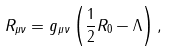<formula> <loc_0><loc_0><loc_500><loc_500>R _ { \mu \nu } = g _ { \mu \nu } \left ( \frac { 1 } { 2 } R _ { 0 } - \Lambda \right ) ,</formula> 